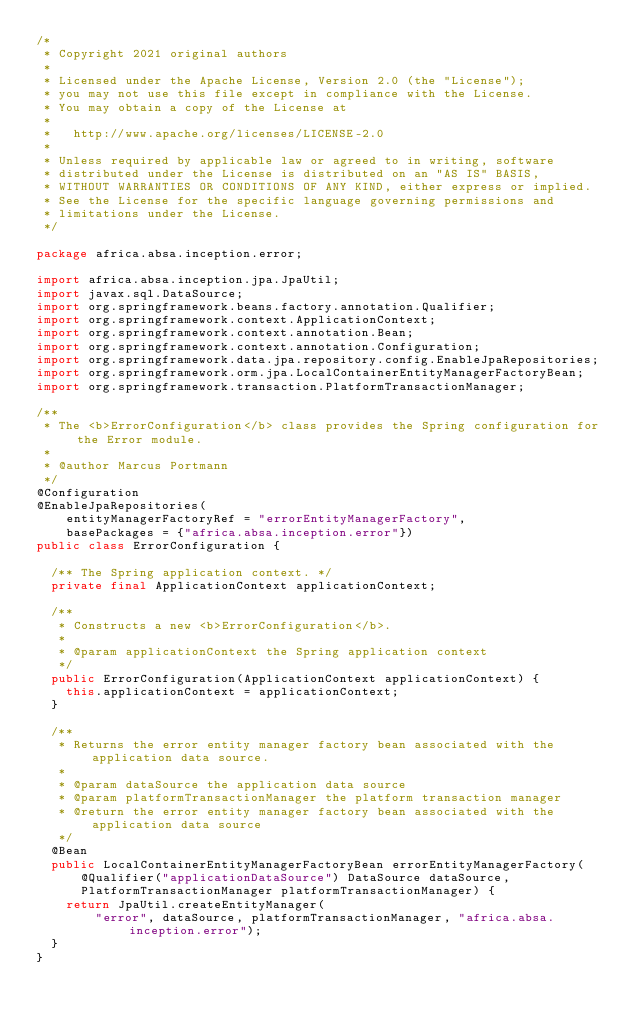Convert code to text. <code><loc_0><loc_0><loc_500><loc_500><_Java_>/*
 * Copyright 2021 original authors
 *
 * Licensed under the Apache License, Version 2.0 (the "License");
 * you may not use this file except in compliance with the License.
 * You may obtain a copy of the License at
 *
 *   http://www.apache.org/licenses/LICENSE-2.0
 *
 * Unless required by applicable law or agreed to in writing, software
 * distributed under the License is distributed on an "AS IS" BASIS,
 * WITHOUT WARRANTIES OR CONDITIONS OF ANY KIND, either express or implied.
 * See the License for the specific language governing permissions and
 * limitations under the License.
 */

package africa.absa.inception.error;

import africa.absa.inception.jpa.JpaUtil;
import javax.sql.DataSource;
import org.springframework.beans.factory.annotation.Qualifier;
import org.springframework.context.ApplicationContext;
import org.springframework.context.annotation.Bean;
import org.springframework.context.annotation.Configuration;
import org.springframework.data.jpa.repository.config.EnableJpaRepositories;
import org.springframework.orm.jpa.LocalContainerEntityManagerFactoryBean;
import org.springframework.transaction.PlatformTransactionManager;

/**
 * The <b>ErrorConfiguration</b> class provides the Spring configuration for the Error module.
 *
 * @author Marcus Portmann
 */
@Configuration
@EnableJpaRepositories(
    entityManagerFactoryRef = "errorEntityManagerFactory",
    basePackages = {"africa.absa.inception.error"})
public class ErrorConfiguration {

  /** The Spring application context. */
  private final ApplicationContext applicationContext;

  /**
   * Constructs a new <b>ErrorConfiguration</b>.
   *
   * @param applicationContext the Spring application context
   */
  public ErrorConfiguration(ApplicationContext applicationContext) {
    this.applicationContext = applicationContext;
  }

  /**
   * Returns the error entity manager factory bean associated with the application data source.
   *
   * @param dataSource the application data source
   * @param platformTransactionManager the platform transaction manager
   * @return the error entity manager factory bean associated with the application data source
   */
  @Bean
  public LocalContainerEntityManagerFactoryBean errorEntityManagerFactory(
      @Qualifier("applicationDataSource") DataSource dataSource,
      PlatformTransactionManager platformTransactionManager) {
    return JpaUtil.createEntityManager(
        "error", dataSource, platformTransactionManager, "africa.absa.inception.error");
  }
}
</code> 